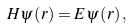Convert formula to latex. <formula><loc_0><loc_0><loc_500><loc_500>H \psi \left ( r \right ) = E \psi \left ( r \right ) ,</formula> 